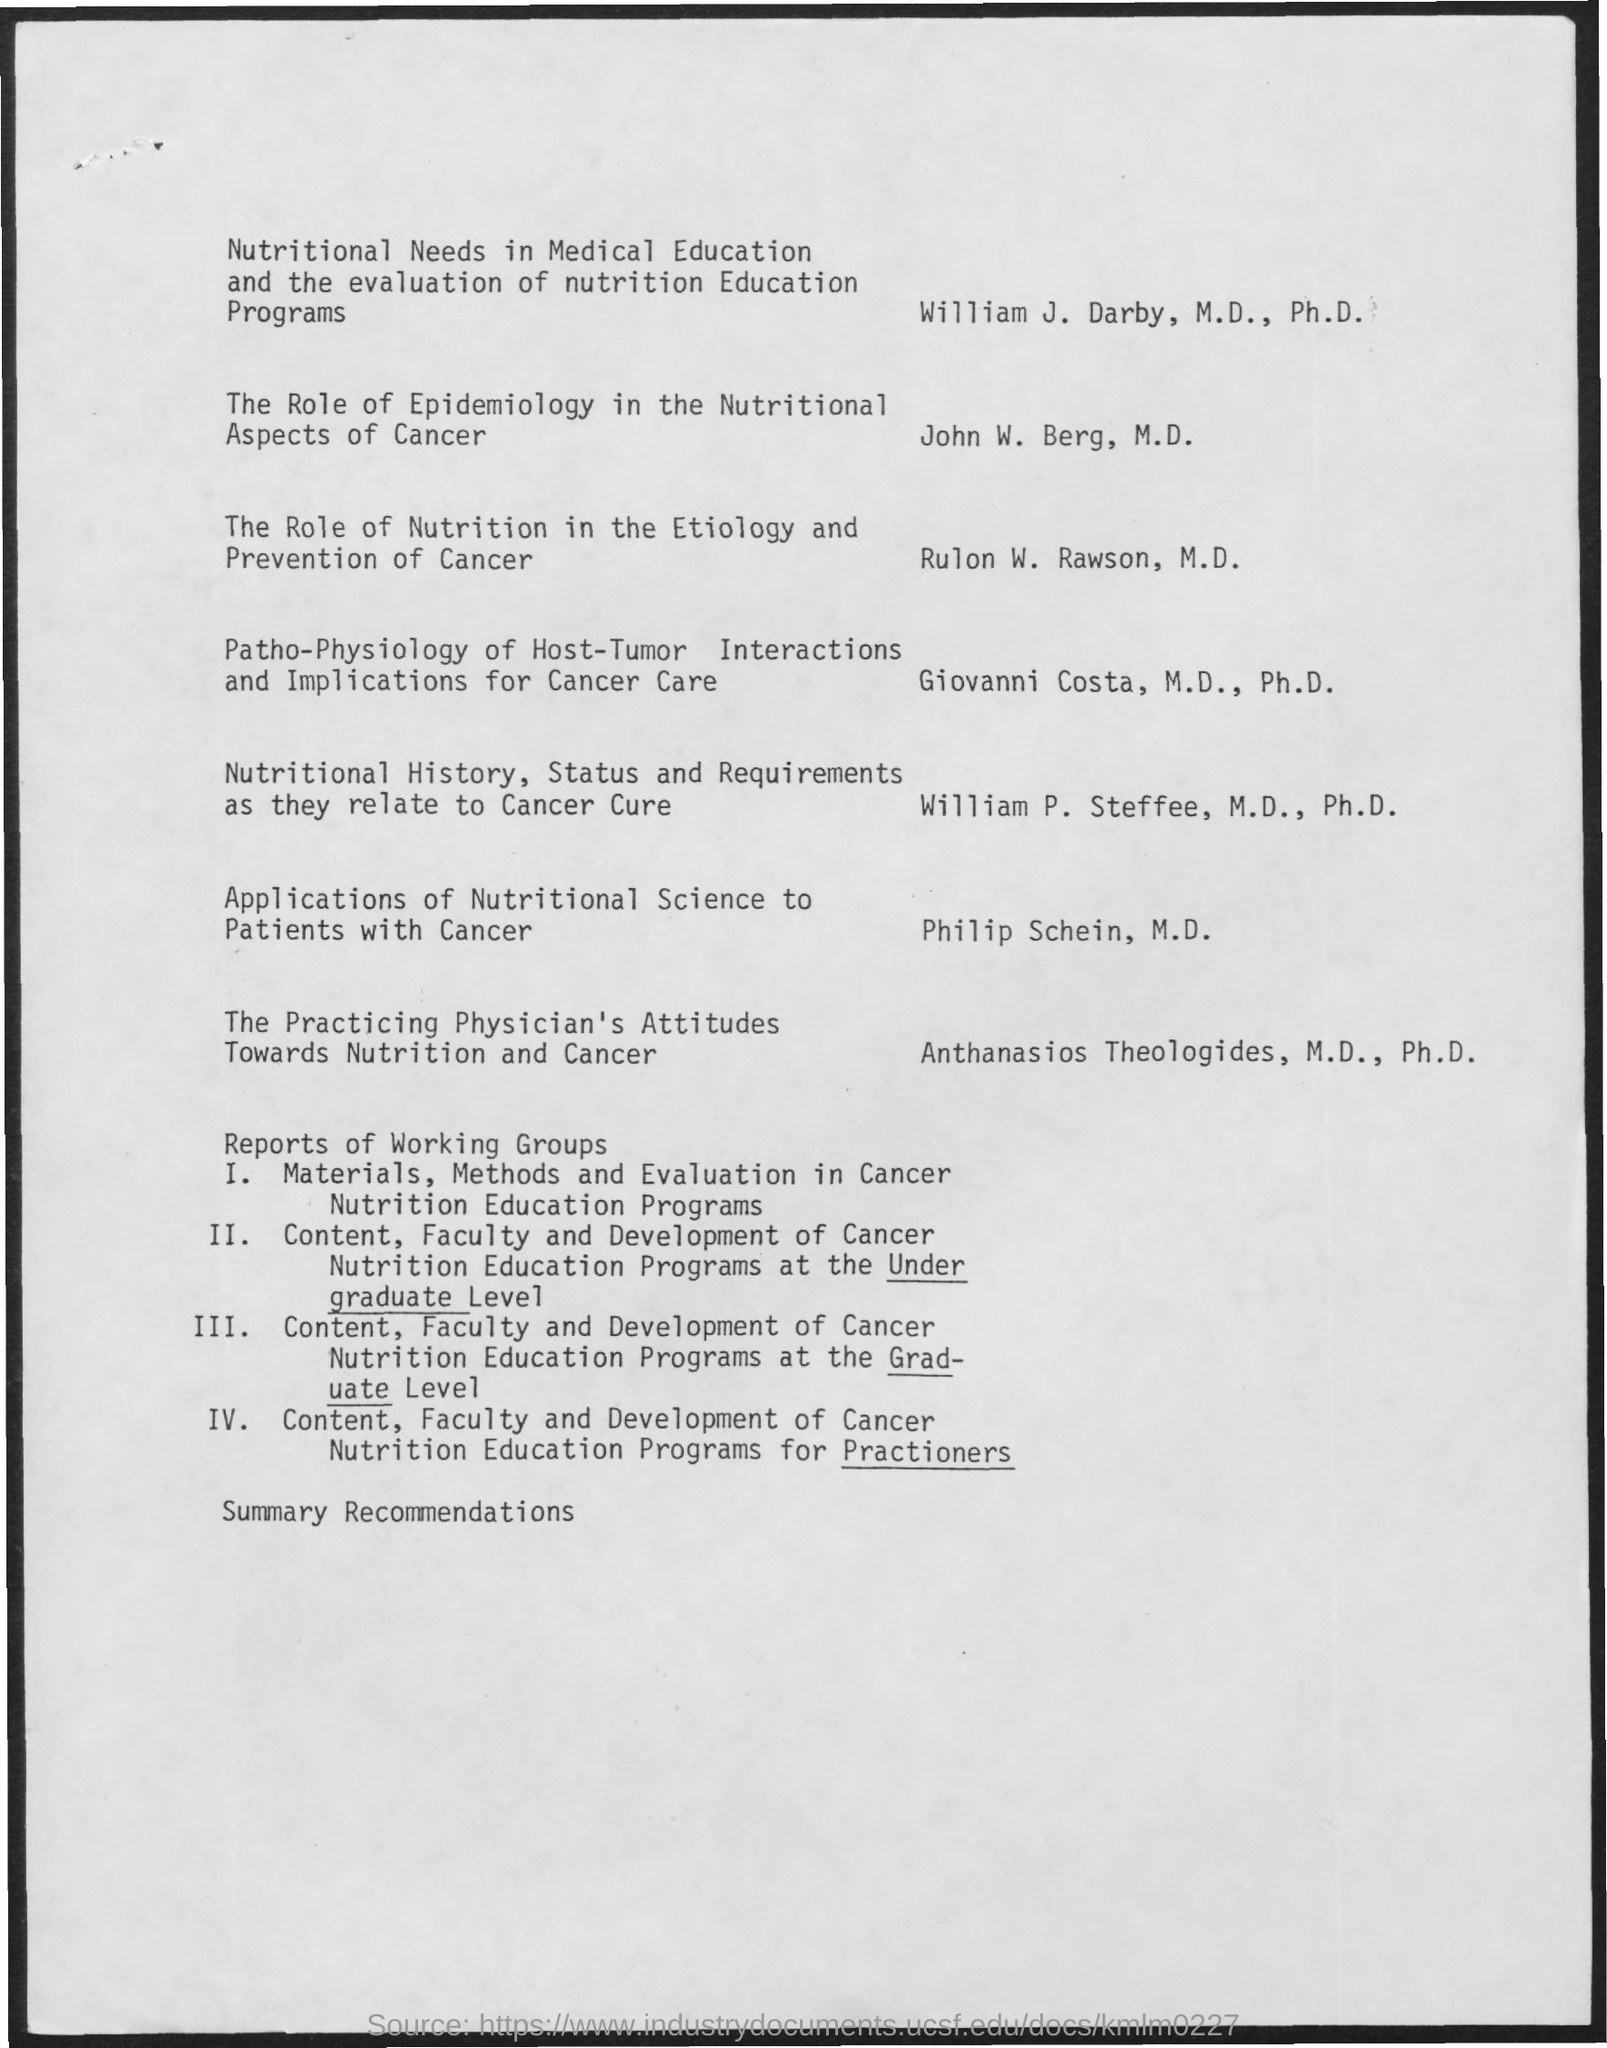Specify some key components in this picture. The article "The Role of Epidemology in the Nutritional Aspects of Cancer" was written by John W. Berg, M.D. Rulon W. Rawson, M.D., wrote the article titled "The Role of Nutrition in the Etiology and Prevention of Cancer. 